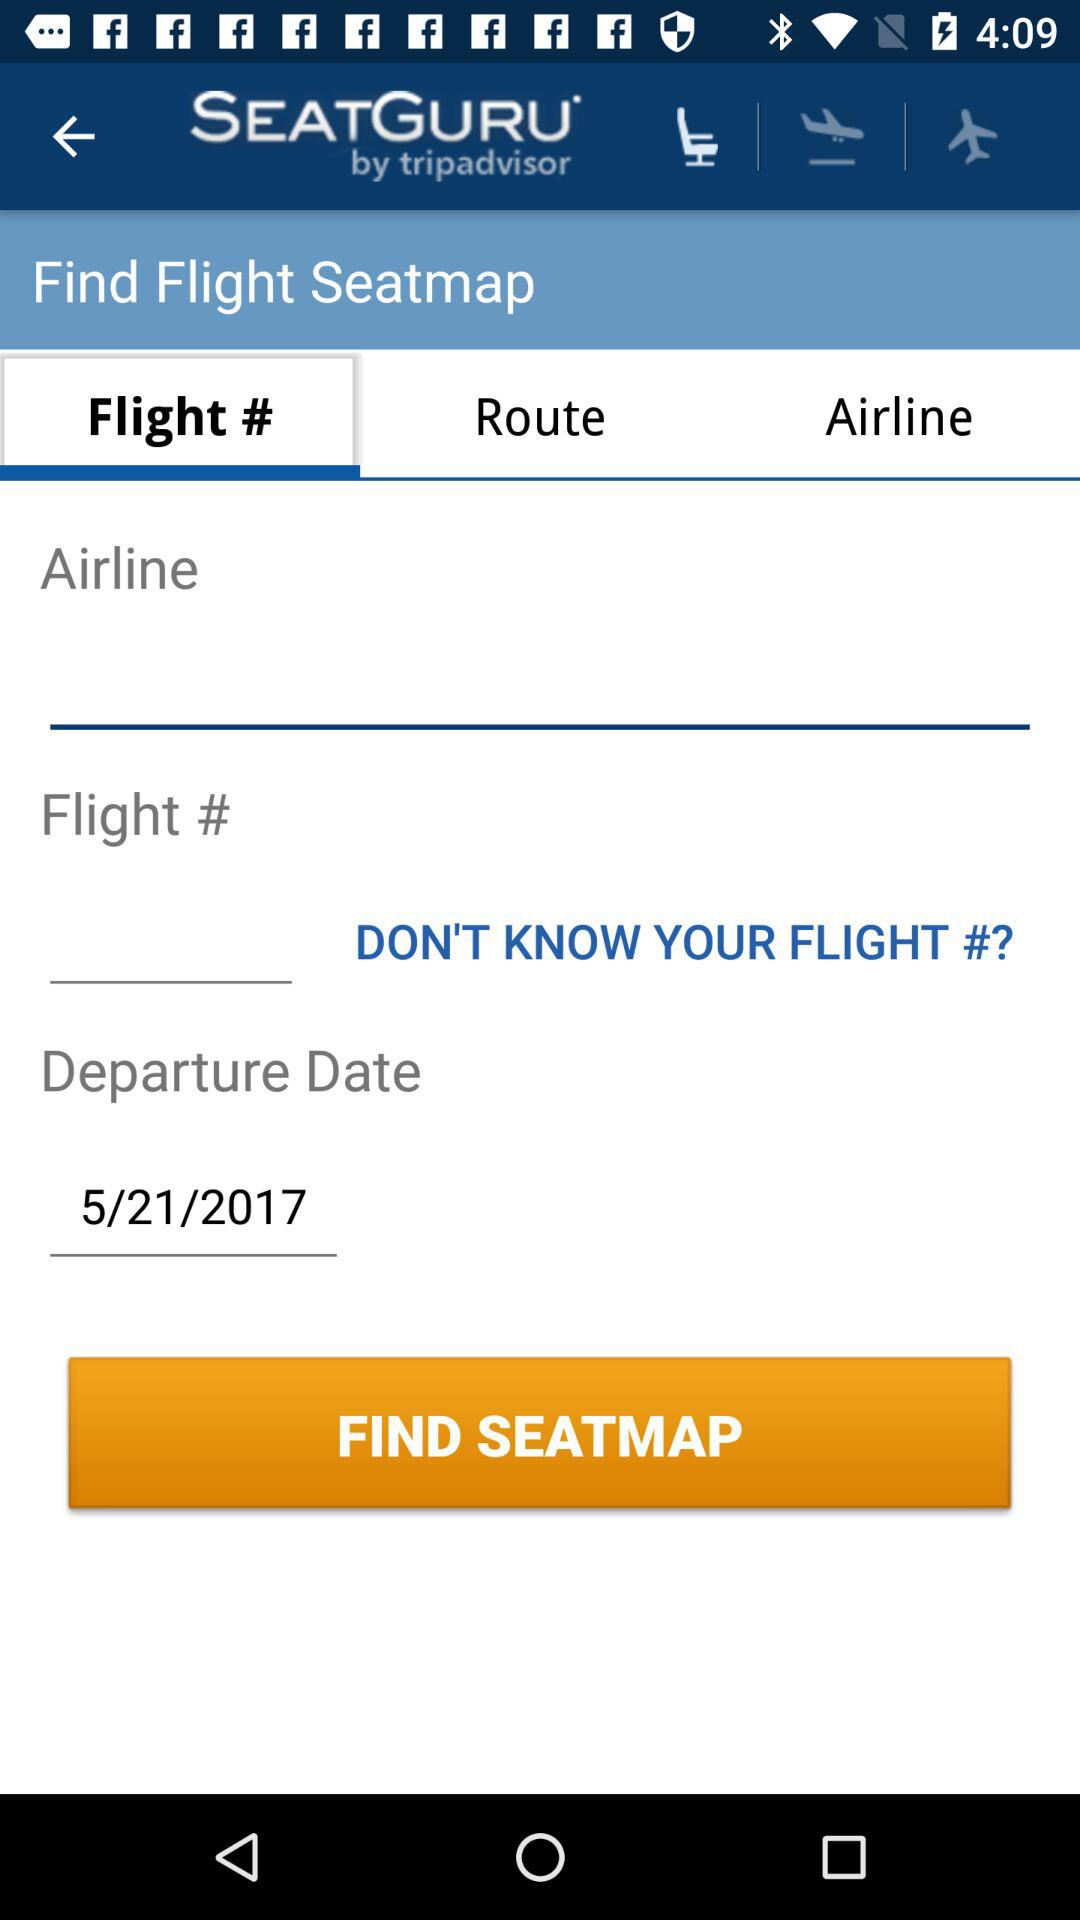What is the flight number?
When the provided information is insufficient, respond with <no answer>. <no answer> 